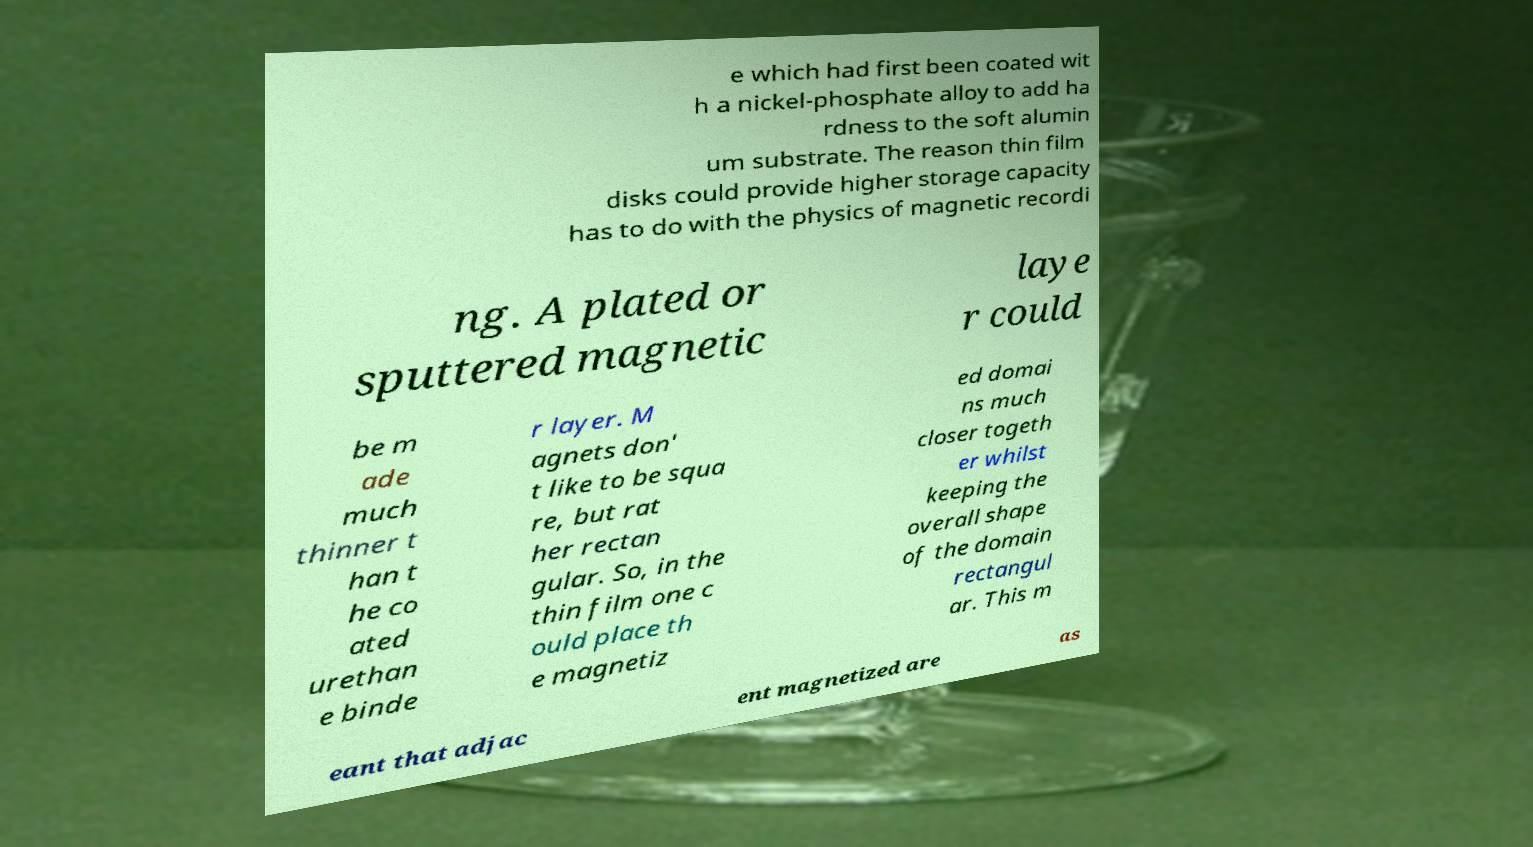What messages or text are displayed in this image? I need them in a readable, typed format. e which had first been coated wit h a nickel-phosphate alloy to add ha rdness to the soft alumin um substrate. The reason thin film disks could provide higher storage capacity has to do with the physics of magnetic recordi ng. A plated or sputtered magnetic laye r could be m ade much thinner t han t he co ated urethan e binde r layer. M agnets don' t like to be squa re, but rat her rectan gular. So, in the thin film one c ould place th e magnetiz ed domai ns much closer togeth er whilst keeping the overall shape of the domain rectangul ar. This m eant that adjac ent magnetized are as 